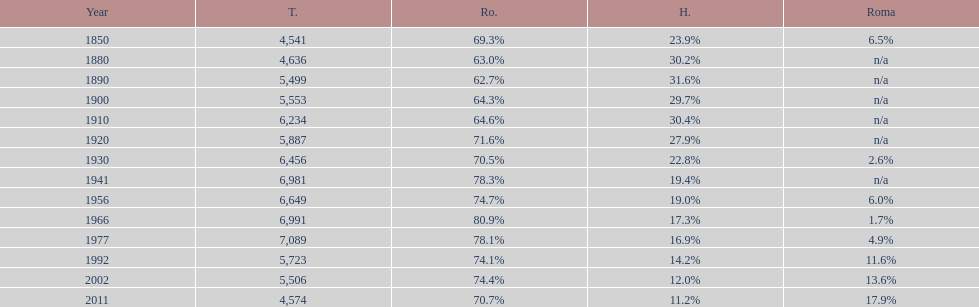Which year had a total of 6,981 and 19.4% hungarians? 1941. 